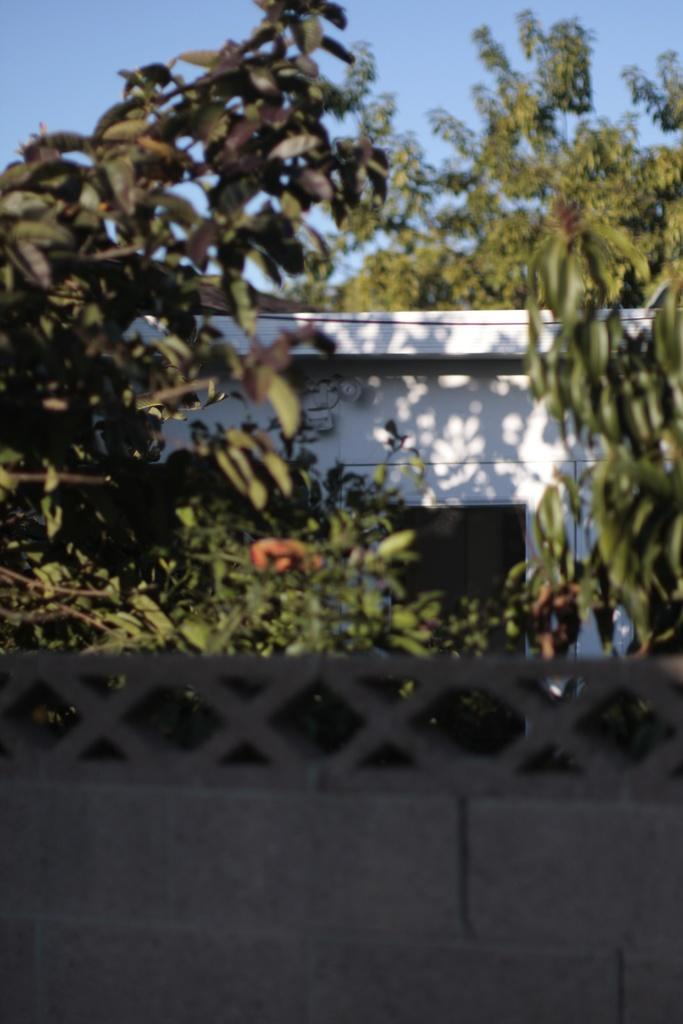What type of natural elements can be seen in the image? There are trees in the image. What colors are the walls in the image? The walls in the image are white and ash colored. Can you see any animals from the zoo in the image? There is no zoo or animals present in the image; it features trees and walls. What type of nerve is visible in the image? There is no nerve present in the image; it features trees and walls. 